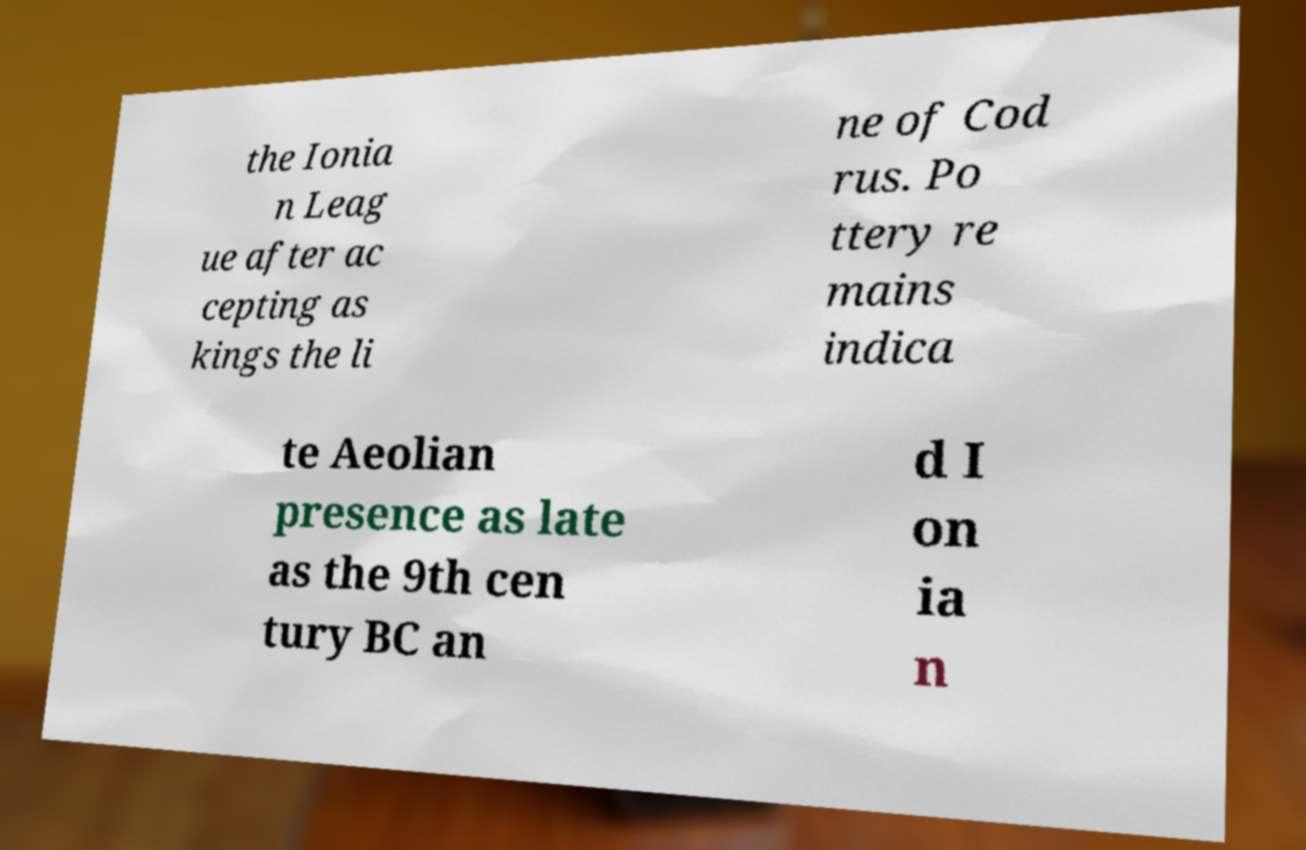Could you assist in decoding the text presented in this image and type it out clearly? the Ionia n Leag ue after ac cepting as kings the li ne of Cod rus. Po ttery re mains indica te Aeolian presence as late as the 9th cen tury BC an d I on ia n 